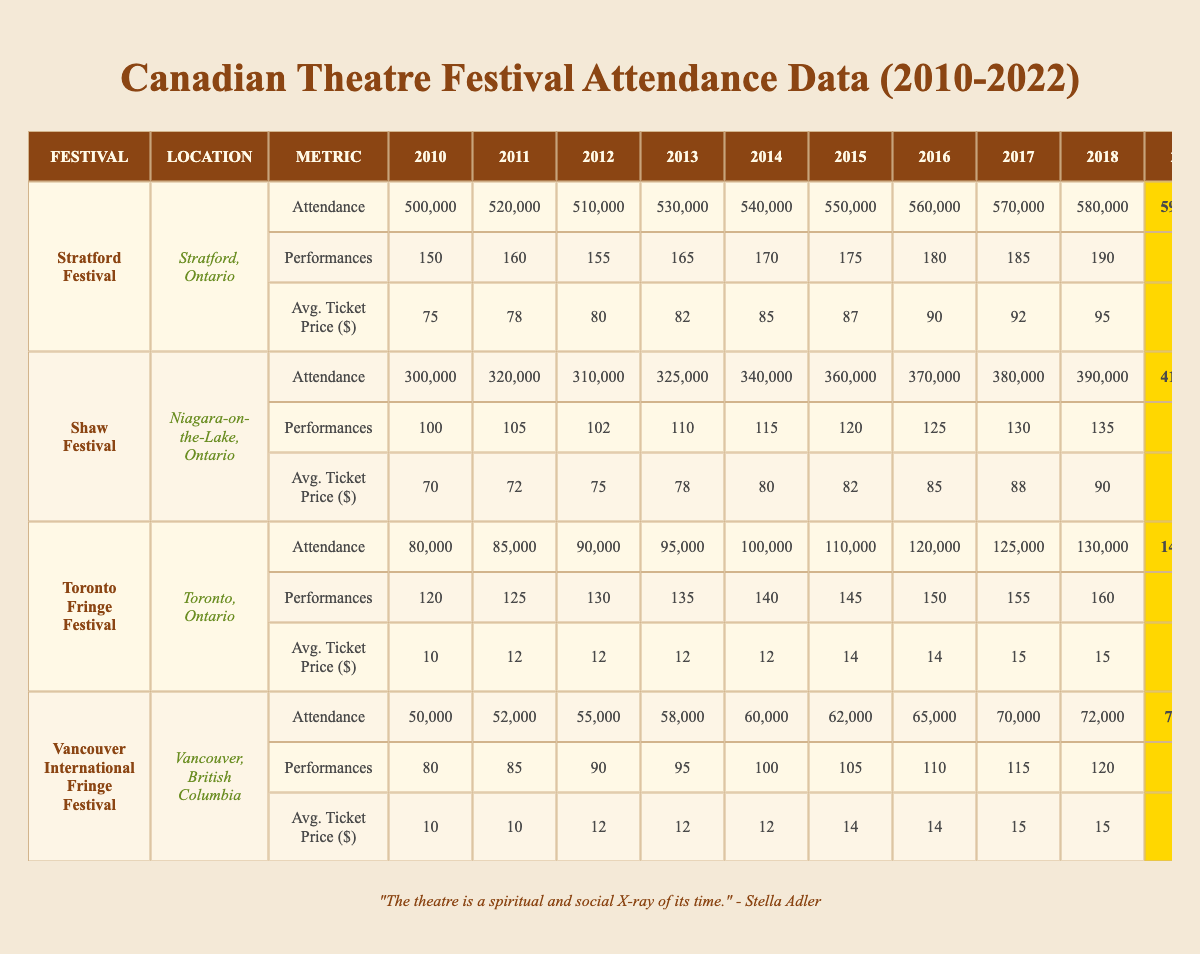What was the highest attendance at the Stratford Festival between 2010 and 2022? The highest attendance figure in the table for the Stratford Festival is found in 2019, with a value of 590,000.
Answer: 590,000 Which festival had the lowest average ticket price in 2010? The table shows that the Toronto Fringe Festival had the lowest average ticket price in 2010 at $10.
Answer: $10 How much did attendance increase from 2010 to 2019 at the Shaw Festival? The attendance in 2010 was 300,000, and in 2019 it was 410,000. The increase is calculated as 410,000 - 300,000 = 110,000.
Answer: 110,000 What was the total attendance for the Toronto Fringe Festival in 2021 and 2022? The attendance in 2021 was 50,000 and in 2022 was 80,000. Adding them gives 50,000 + 80,000 = 130,000.
Answer: 130,000 Did the Vancouver International Fringe Festival have more or less than 60,000 attendees in 2015? The attendance in 2015 was 62,000, which is more than 60,000.
Answer: More Which festival had the highest average ticket price in 2019? According to the table, the Stratford Festival had the highest average ticket price in 2019 at $98.
Answer: $98 What is the percentage decline in attendance at the Shaw Festival from 2019 to 2020? The attendance in 2019 was 410,000 and in 2020 it decreased to 150,000. The decline is calculated as (410,000 - 150,000) / 410,000 * 100 = 63.41%.
Answer: 63.41% What was the average attendance at the Vancouver International Fringe Festival from 2010 to 2022? Sum the attendances from each year (50,000 + 52,000 + 55,000 + 58,000 + 60,000 + 62,000 + 65,000 + 70,000 + 72,000 + 74,000 + 20,000 + 25,000 + 45,000 = 65,000). Divide by the number of years, 13, yielding an average attendance of approximately 65,000.
Answer: 65,000 In which year did the Toronto Fringe Festival have the highest number of performances? The table indicates that the Toronto Fringe Festival had its highest number of performances in 2019 with a total of 165 performances.
Answer: 165 Was the attendance at the Shaw Festival in 2022 higher than that at the Vancouver International Fringe Festival in the same year? The attendance at the Shaw Festival in 2022 was 250,000, while at the Vancouver International Fringe Festival it was 45,000. Thus, the attendance at the Shaw Festival was indeed higher.
Answer: Yes How did the average ticket price change at the Stratford Festival between 2010 and 2022? The average ticket price in 2010 was $75 and in 2022 it was $88. The change is calculated as $88 - $75 = $13 increase.
Answer: $13 increase 